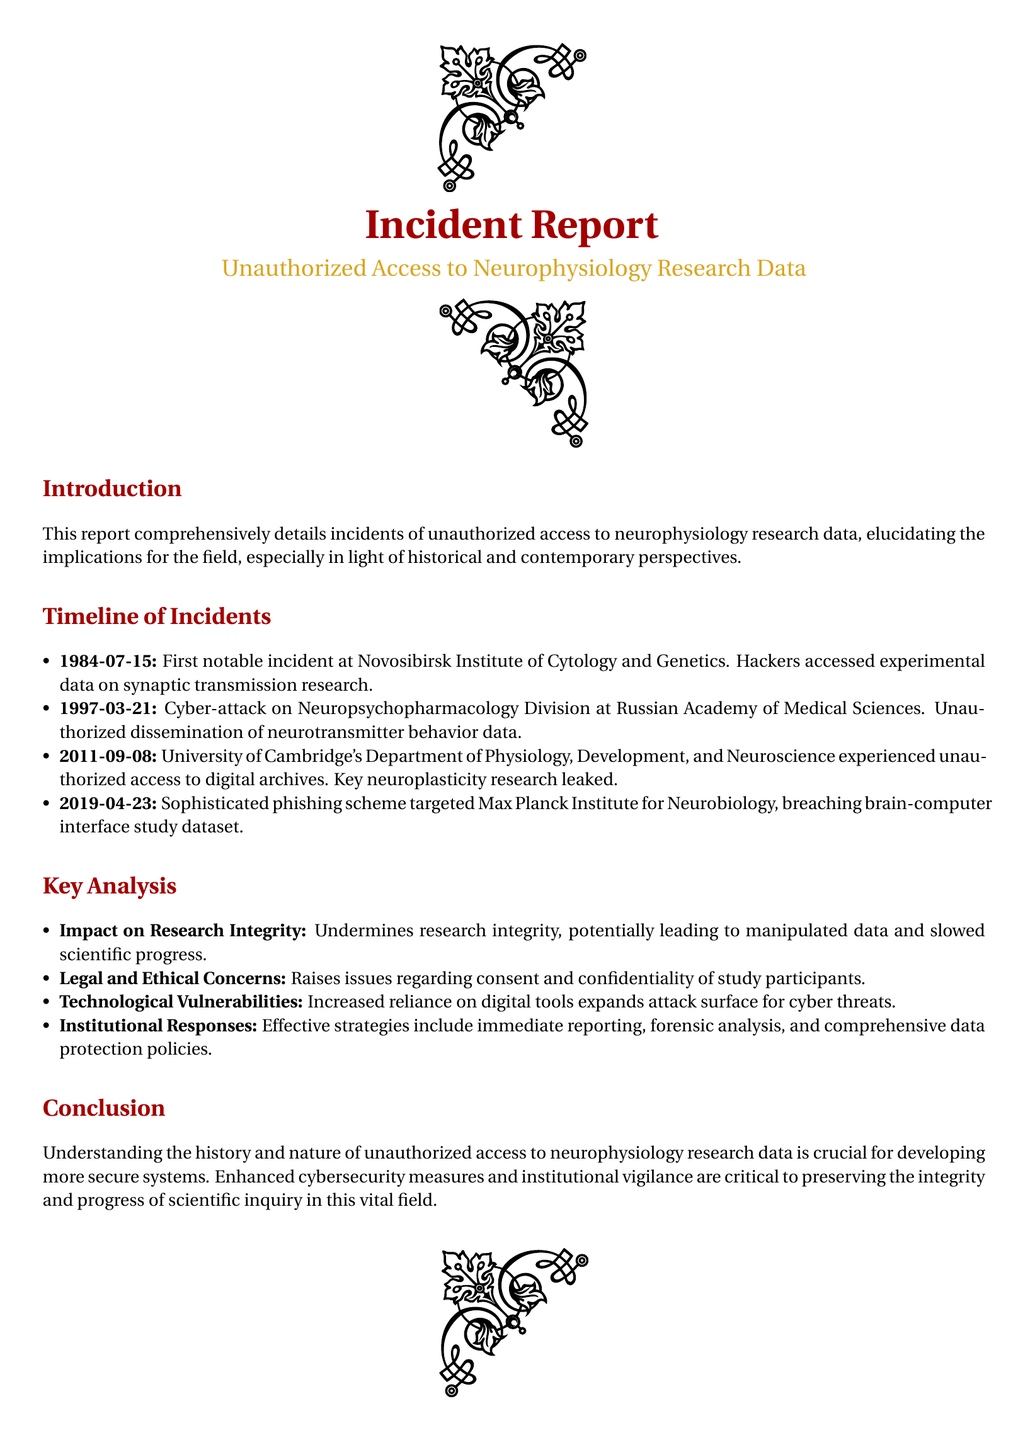What was the date of the first notable incident? The first notable incident occurred on July 15, 1984, at the Novosibirsk Institute of Cytology and Genetics.
Answer: July 15, 1984 Which research division was targeted in the 1997 cyber-attack? The cyber-attack in 1997 targeted the Neuropsychopharmacology Division at the Russian Academy of Medical Sciences.
Answer: Neuropsychopharmacology Division What key aspect of research was leaked in 2011? The unauthorized access in 2011 led to the leaking of key neuroplasticity research.
Answer: Neuroplasticity research How does unauthorized access affect research integrity? Unauthorized access undermines research integrity, potentially leading to manipulated data and slowed scientific progress.
Answer: Research integrity What was one of the institutional responses to unauthorized access incidents? Effective responses include immediate reporting, forensic analysis, and comprehensive data protection policies.
Answer: Immediate reporting Which institution experienced a phishing scheme breach in 2019? The Max Planck Institute for Neurobiology experienced a phishing scheme breach in 2019.
Answer: Max Planck Institute for Neurobiology What is a consequence of increased reliance on digital tools according to the report? Increased reliance on digital tools expands the attack surface for cyber threats.
Answer: Cyber threats What is a major legal concern raised by unauthorized data access? Unauthorized access raises issues regarding consent and confidentiality of study participants.
Answer: Consent and confidentiality What is the overall purpose of this incident report? The report aims to detail incidents of unauthorized access and their implications for research integrity.
Answer: Detail incidents and implications 